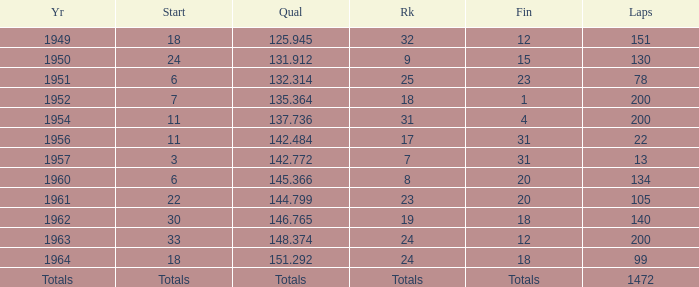Name the rank for laps less than 130 and year of 1951 25.0. 